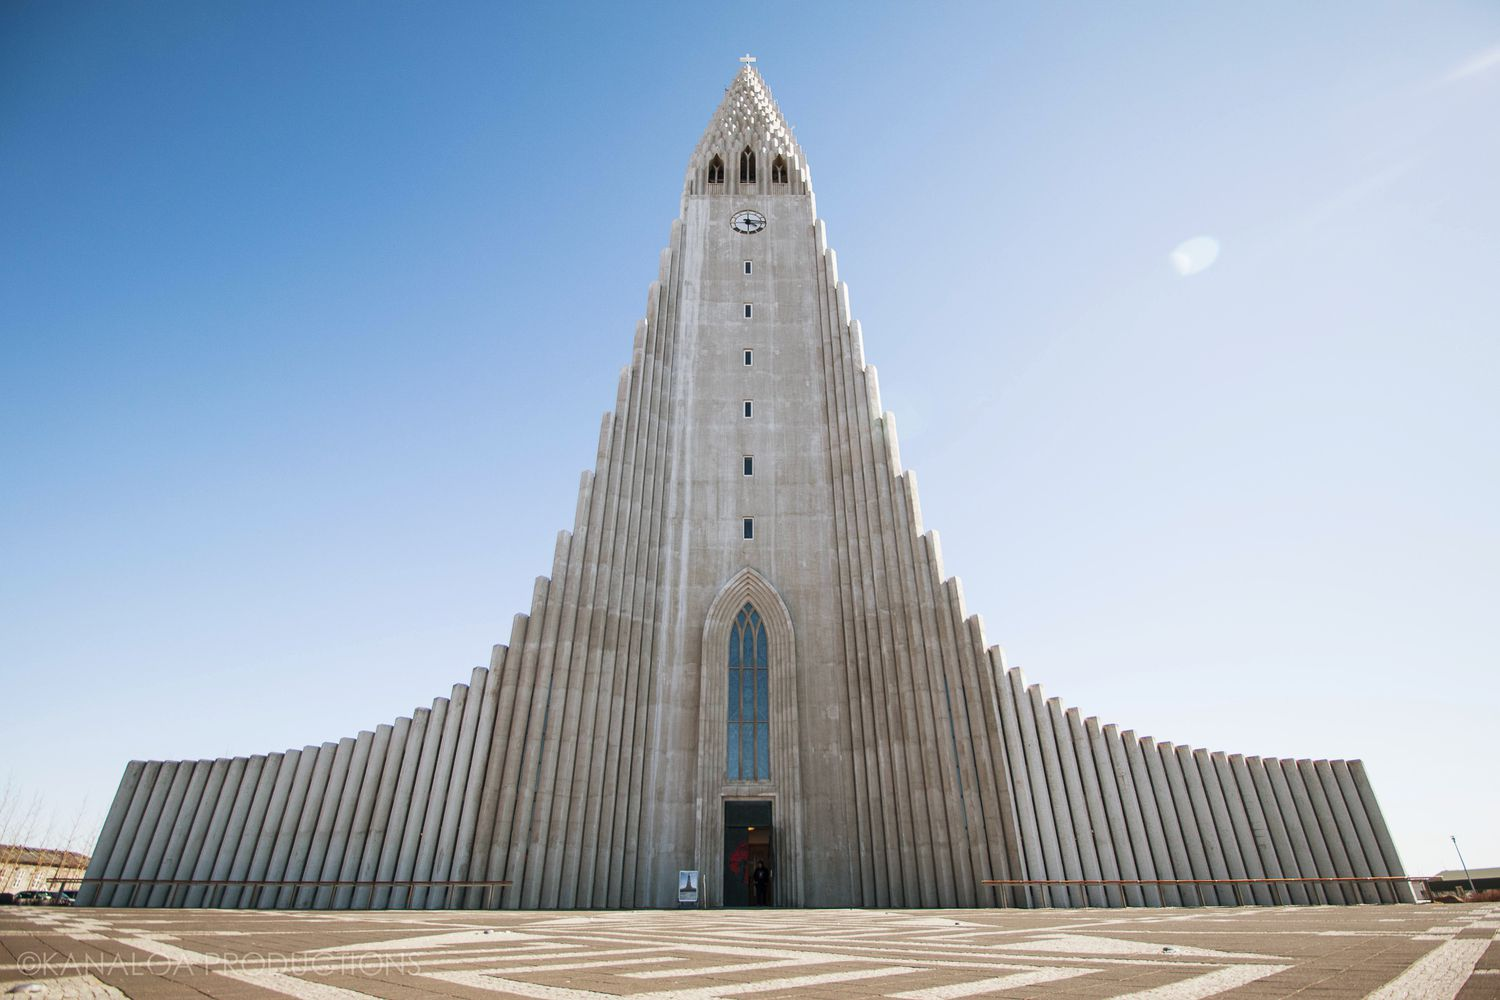Imagine a scenario where this church plays a significant role in a historical event. What might that be? In an alternate history, imagine Hallgrímskirkja as the focal point of a significant diplomatic summit between nations. Dignitaries from around the world gather in Reykjavík, drawn by the church's unique architecture and serene environment. The church's vast interior, usually filled with organ music, now resonates with discussions of peace and cooperation. Amidst the towering columns and the backdrop of Iceland’s natural beauty, leaders sign a pivotal treaty heralding a new era of global harmony. This historic event is commemorated annually, with people from far and wide visiting Hallgrímskirkja to celebrate the unity and peace that began within its walls. 